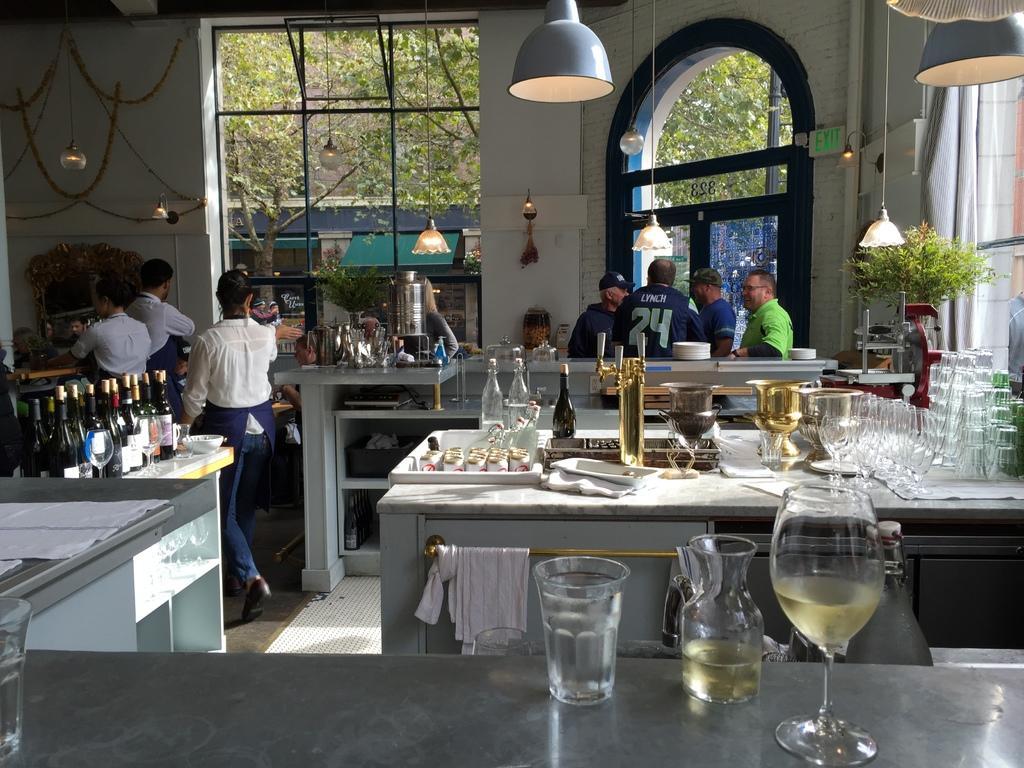How would you summarize this image in a sentence or two? There is a group of people. They are standing. On the right side some persons are wearing a caps and spectacle. There is a table on the right side. There is a glass,plate,bowl,bottle,tray,cups on a table. There is a table on the left side. There is a bottles,bowl and cup on a table. There is an another table in the center. There is glass,wine glass on a table. We can see in the background trees,wall,curtain,plant and wall. 